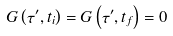Convert formula to latex. <formula><loc_0><loc_0><loc_500><loc_500>G \left ( \tau ^ { \prime } , t _ { i } \right ) = G \left ( \tau ^ { \prime } , t _ { f } \right ) = 0</formula> 